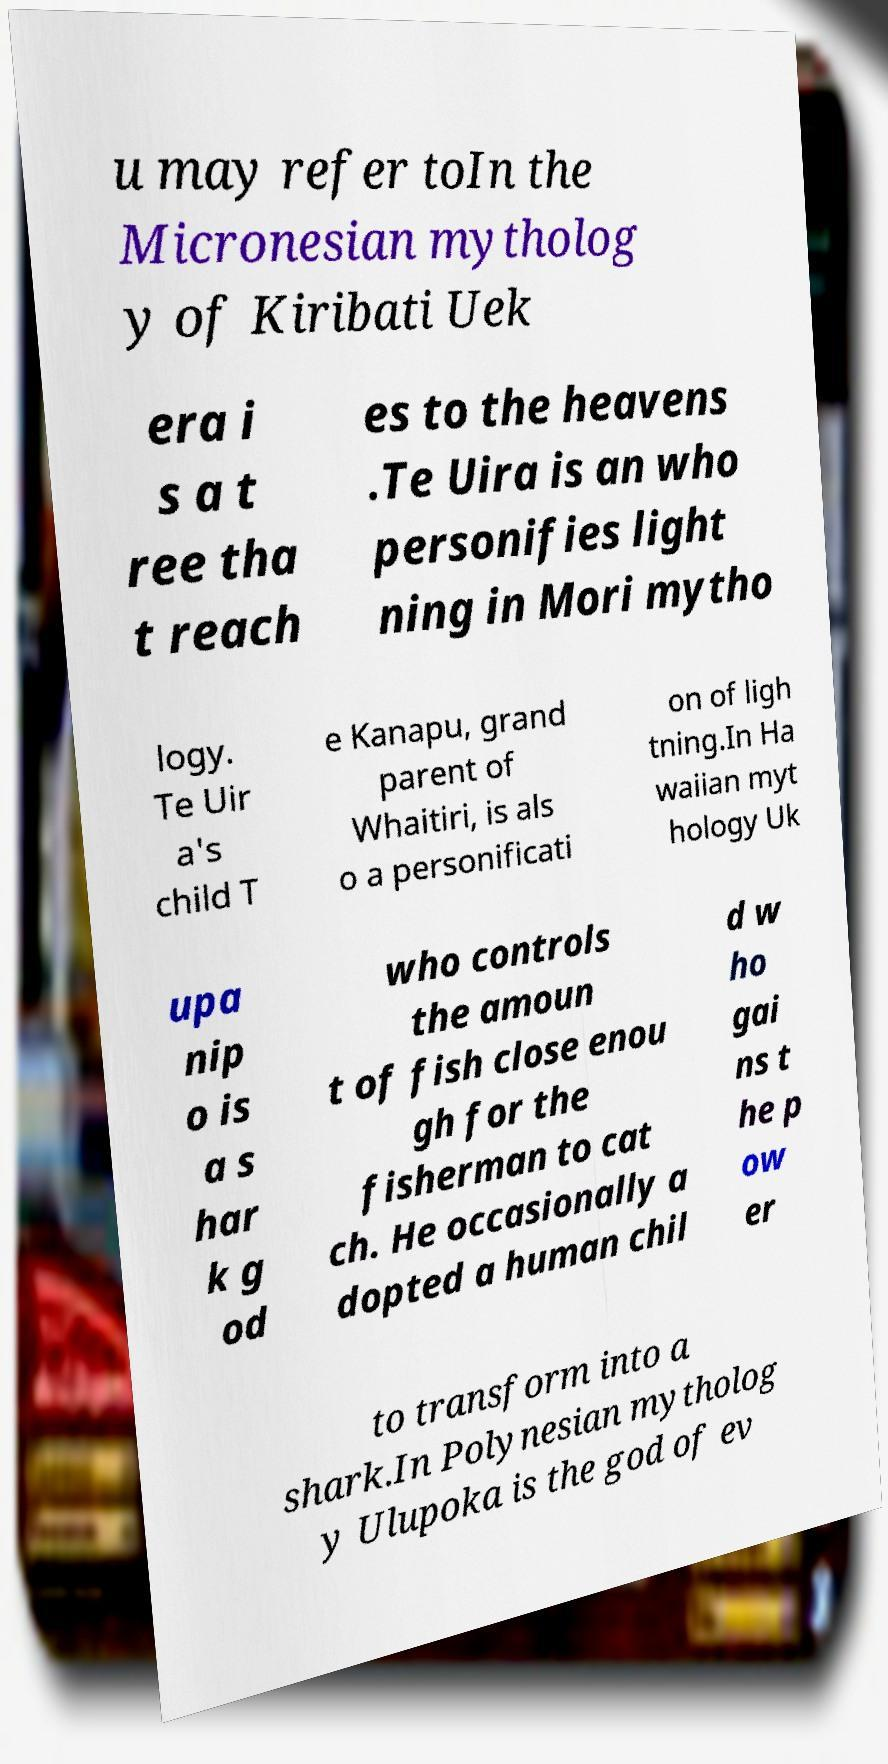Could you assist in decoding the text presented in this image and type it out clearly? u may refer toIn the Micronesian mytholog y of Kiribati Uek era i s a t ree tha t reach es to the heavens .Te Uira is an who personifies light ning in Mori mytho logy. Te Uir a's child T e Kanapu, grand parent of Whaitiri, is als o a personificati on of ligh tning.In Ha waiian myt hology Uk upa nip o is a s har k g od who controls the amoun t of fish close enou gh for the fisherman to cat ch. He occasionally a dopted a human chil d w ho gai ns t he p ow er to transform into a shark.In Polynesian mytholog y Ulupoka is the god of ev 